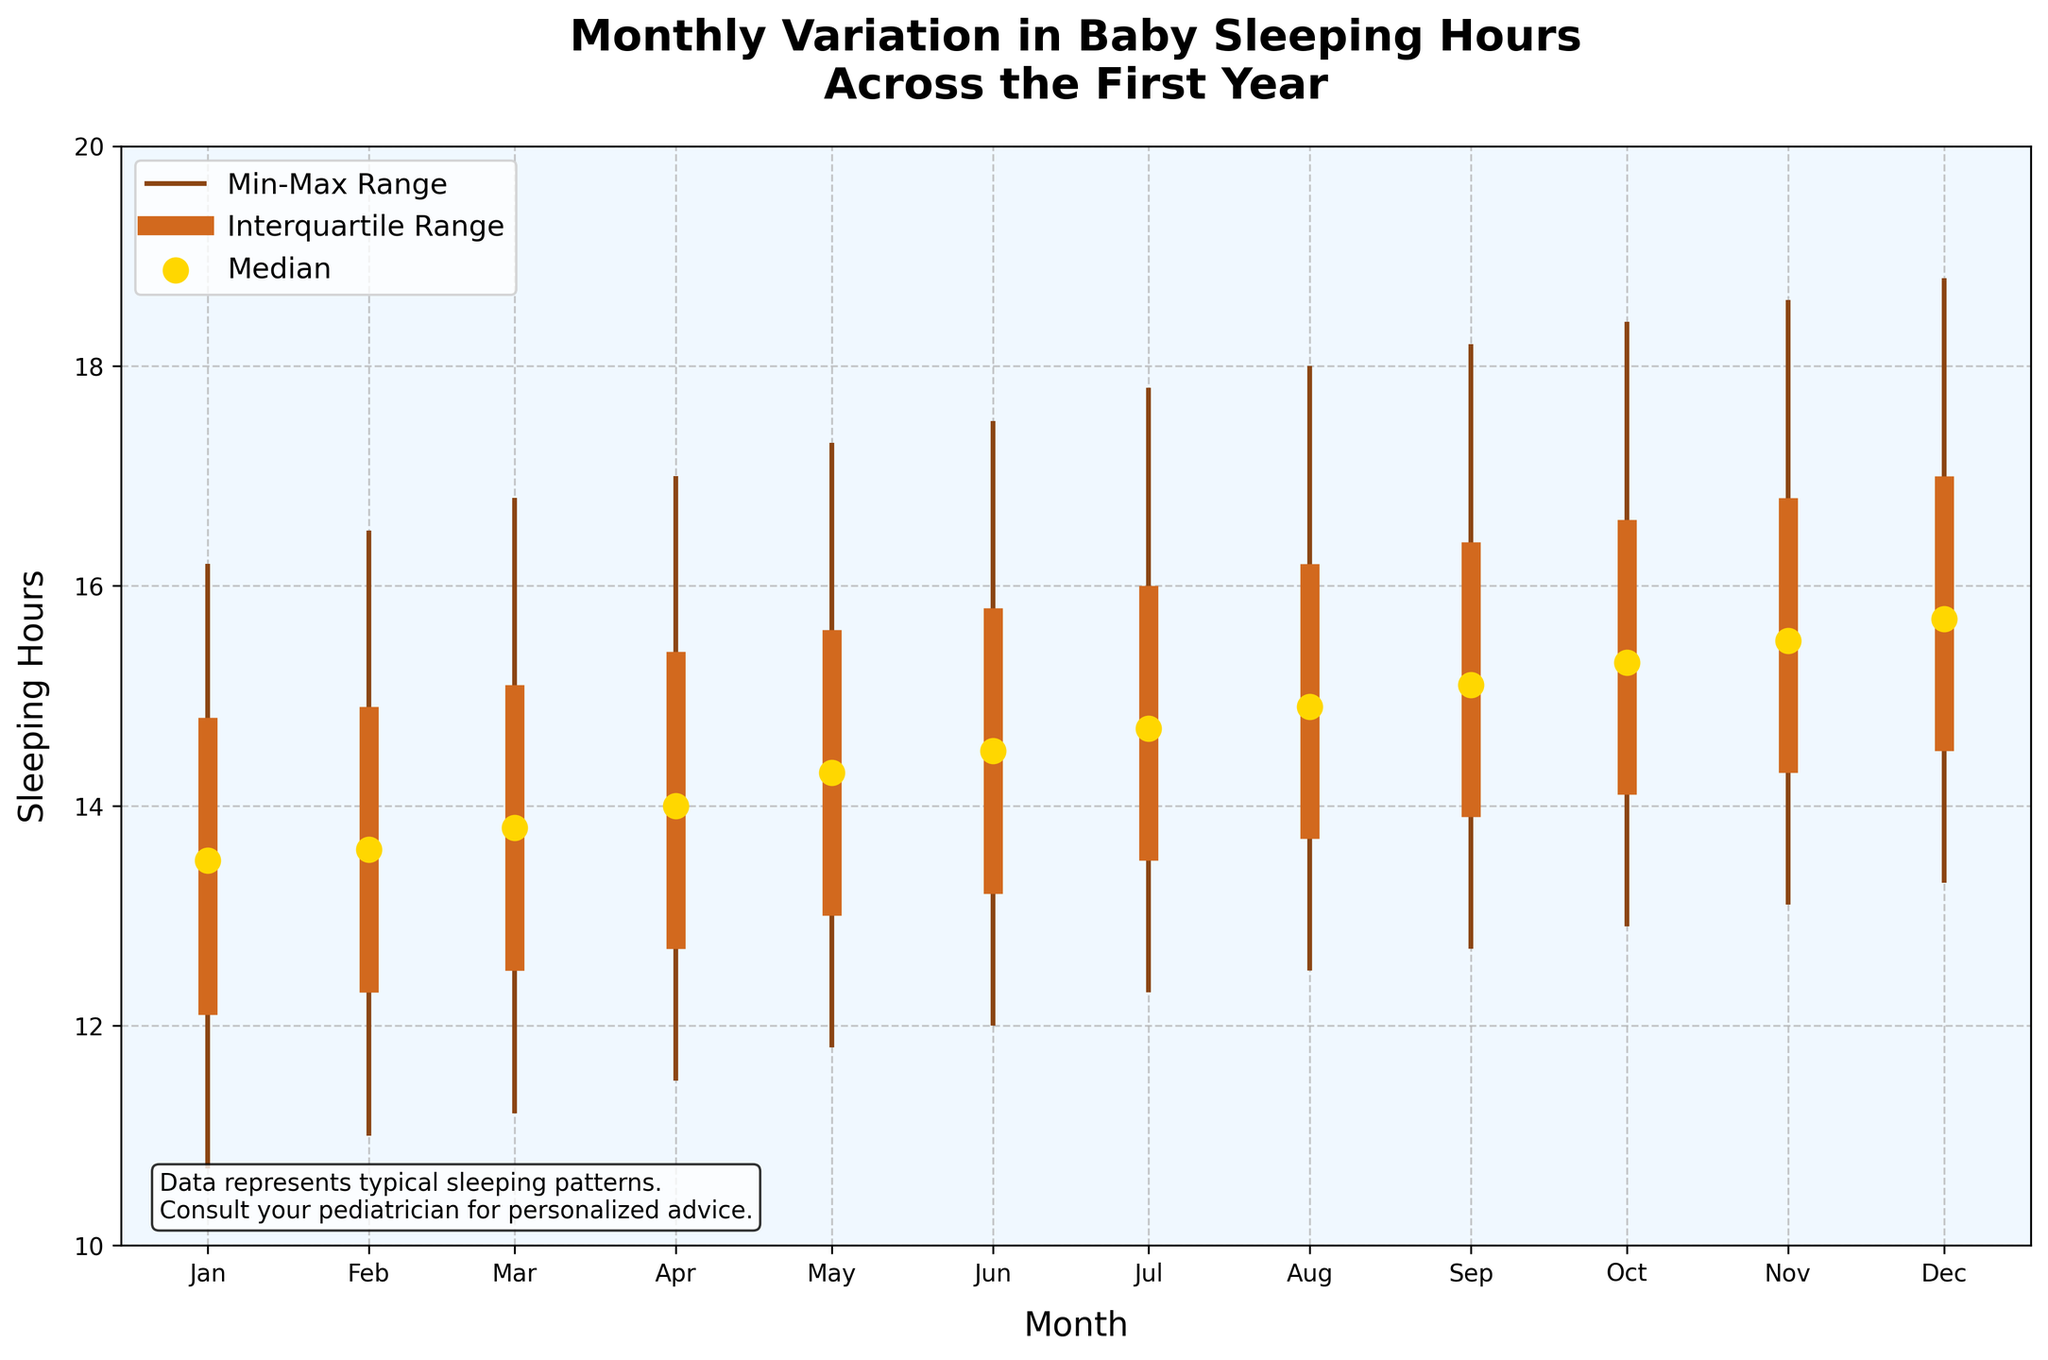what is the title of the plot? Look at the top of the plot for the title.
Answer: Monthly Variation in Baby Sleeping Hours Across the First Year what are the minimum and maximum sleeping hours in June? Locate the June data on the plot and check the candlestick ends for minimum and maximum values.
Answer: 12.0 and 17.5 hours how does the median sleeping time change from January to December? Track the median points (gold dots) from January to December. In January, it's 13.5 hours, and in December, it's 15.7 hours, so it increases.
Answer: Increases Which month has the lowest minimum sleeping hour? Find the shortest lower line in the candlestick plot. It's in January with 10.7 hours.
Answer: January which month shows the widest interquartile range? Compare the length of the thick middle section of the candlesticks. November has the widest interquartile range (14.3 to 16.8 hours, range of 2.5 hours).
Answer: November how many months have a median sleeping hour of at least 15 hours? Count the gold dots that are at or above 15 hours. Starting from September to December, that's 4 months.
Answer: 4 months what is the first quartile sleeping hour in July? Locate the thick middle section of the candlestick for July and check the lower end. It's 13.5 hours.
Answer: 13.5 hours which month has the highest maximum sleeping hour? Look for the topmost end of the candlestick plot. December shows the highest maximum with 18.8 hours.
Answer: December how does the interquartile range change from January to July? Measure the thickness of the middle sections for each month and compare. It gradually increases from January (12.1 to 14.8, range 2.7 hours) to July (13.5 to 16.0, range 2.5 hours).
Answer: Gradually increases compare the median sleeping hour in March and November. Which is higher and by how much? Check the gold dots for March and November. March is 13.8 hours, November is 15.5 hours. Difference: 15.5 - 13.8 = 1.7 hours.
Answer: November, 1.7 hours higher 